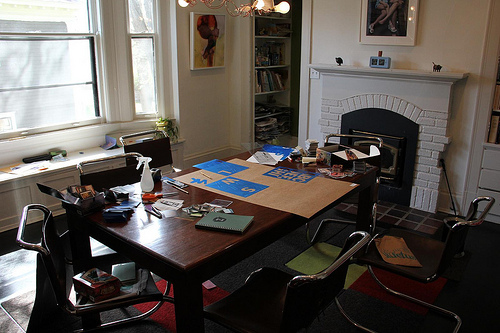<image>
Is there a fireplace on the table? No. The fireplace is not positioned on the table. They may be near each other, but the fireplace is not supported by or resting on top of the table. 